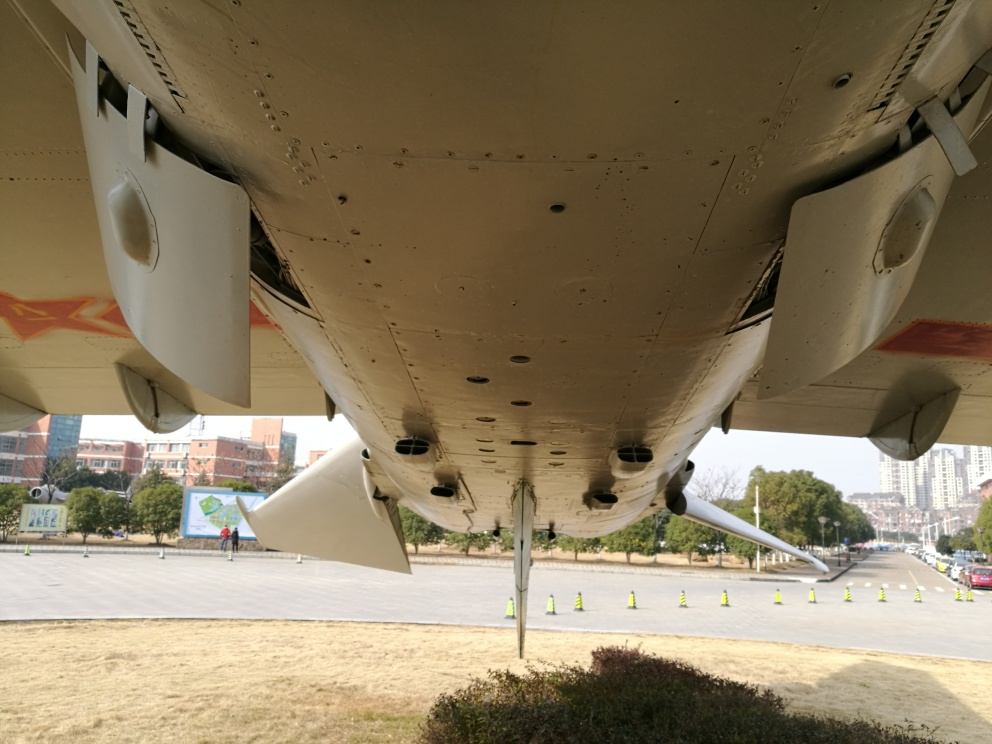Are there any quality issues with this image? While the image generally appears clear, showcasing the underbelly of an aircraft, there are some aspects that detract from its quality. For instance, the overexposure in the sky region results in a loss of detail, and the shadows and darker regions under the aircraft's wings lack some definition. Additionally, there are no immediately noticeable technical defects like blur or noise, but the framing could be improved for a better composition. The presence of a person on the left-hand side adds a sense of scale, yet they are partially cut off which might be seen as a compositional weakness. 